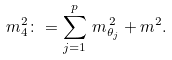Convert formula to latex. <formula><loc_0><loc_0><loc_500><loc_500>m _ { 4 } ^ { 2 } \colon = \sum _ { j = 1 } ^ { p } \, m _ { \theta _ { j } } ^ { \, 2 } + m ^ { 2 } .</formula> 